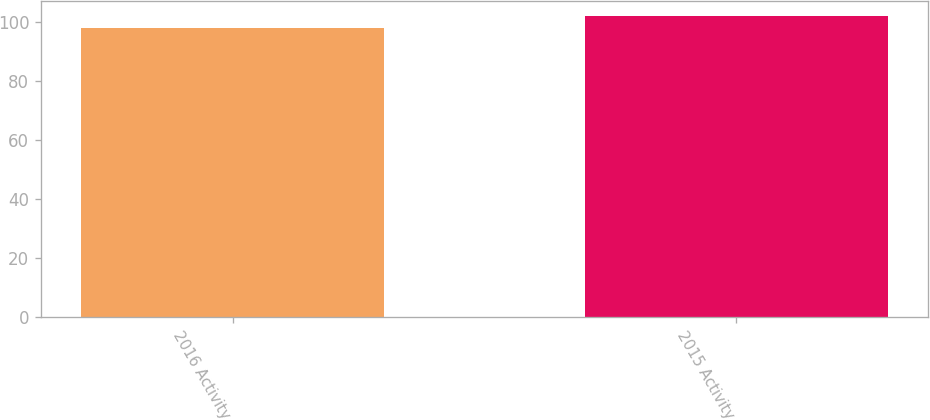Convert chart. <chart><loc_0><loc_0><loc_500><loc_500><bar_chart><fcel>2016 Activity<fcel>2015 Activity<nl><fcel>98<fcel>102<nl></chart> 